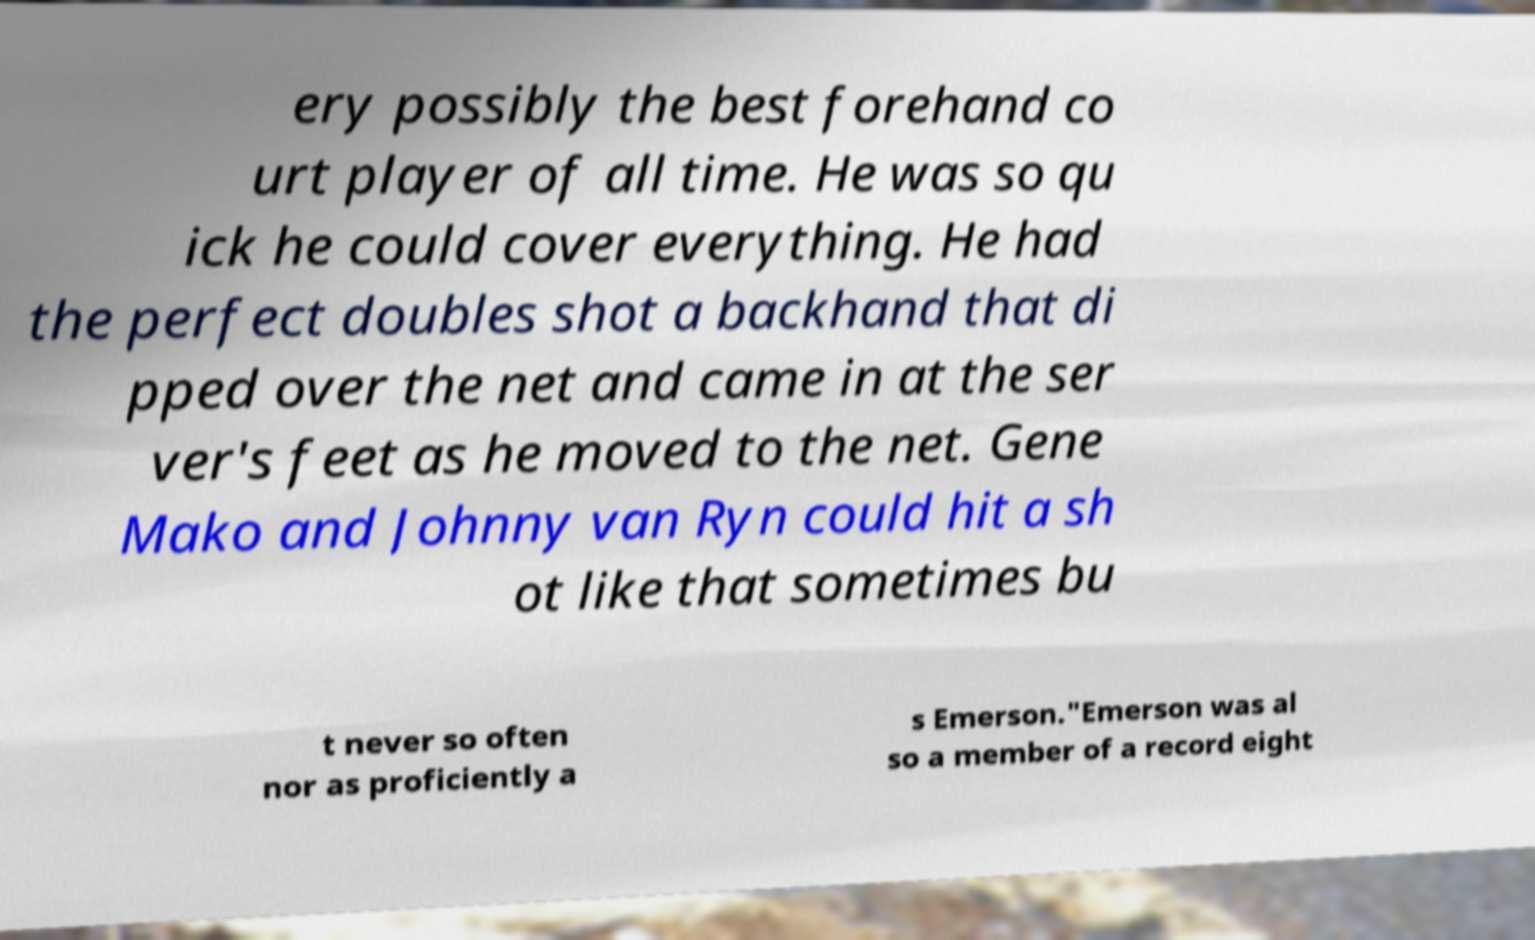Can you read and provide the text displayed in the image?This photo seems to have some interesting text. Can you extract and type it out for me? ery possibly the best forehand co urt player of all time. He was so qu ick he could cover everything. He had the perfect doubles shot a backhand that di pped over the net and came in at the ser ver's feet as he moved to the net. Gene Mako and Johnny van Ryn could hit a sh ot like that sometimes bu t never so often nor as proficiently a s Emerson."Emerson was al so a member of a record eight 